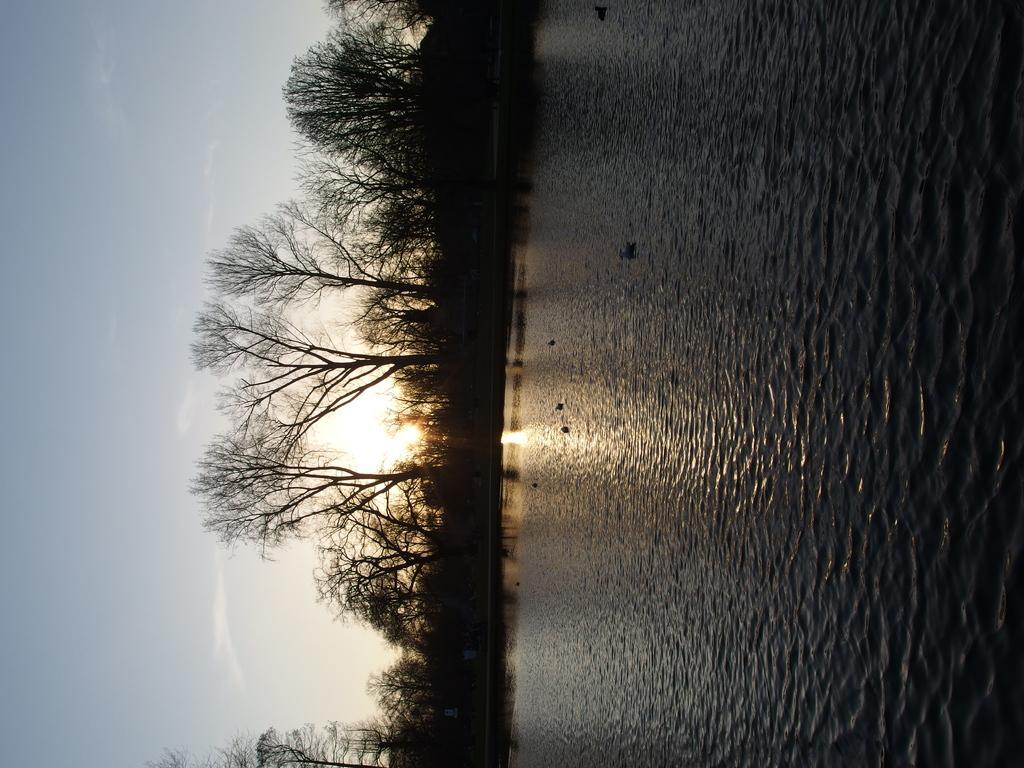How would you summarize this image in a sentence or two? This picture is clicked outside. On the right we can see the water body. In the background there is a sky, sunlight, trees and some other objects. 